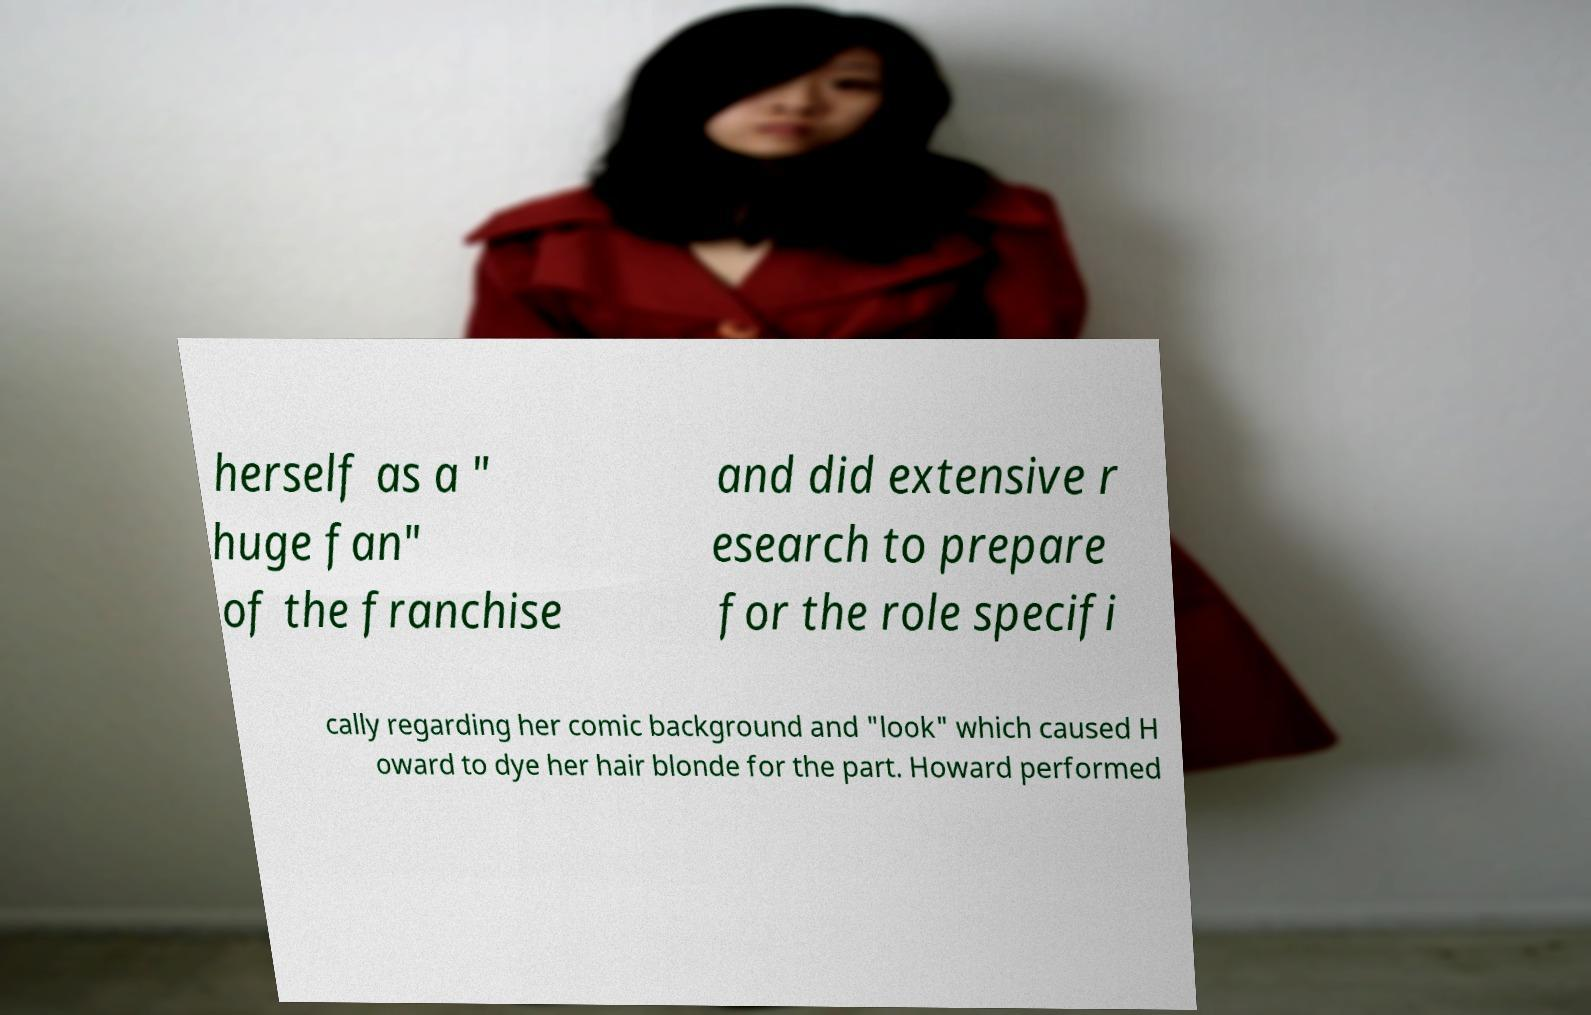Please identify and transcribe the text found in this image. herself as a " huge fan" of the franchise and did extensive r esearch to prepare for the role specifi cally regarding her comic background and "look" which caused H oward to dye her hair blonde for the part. Howard performed 